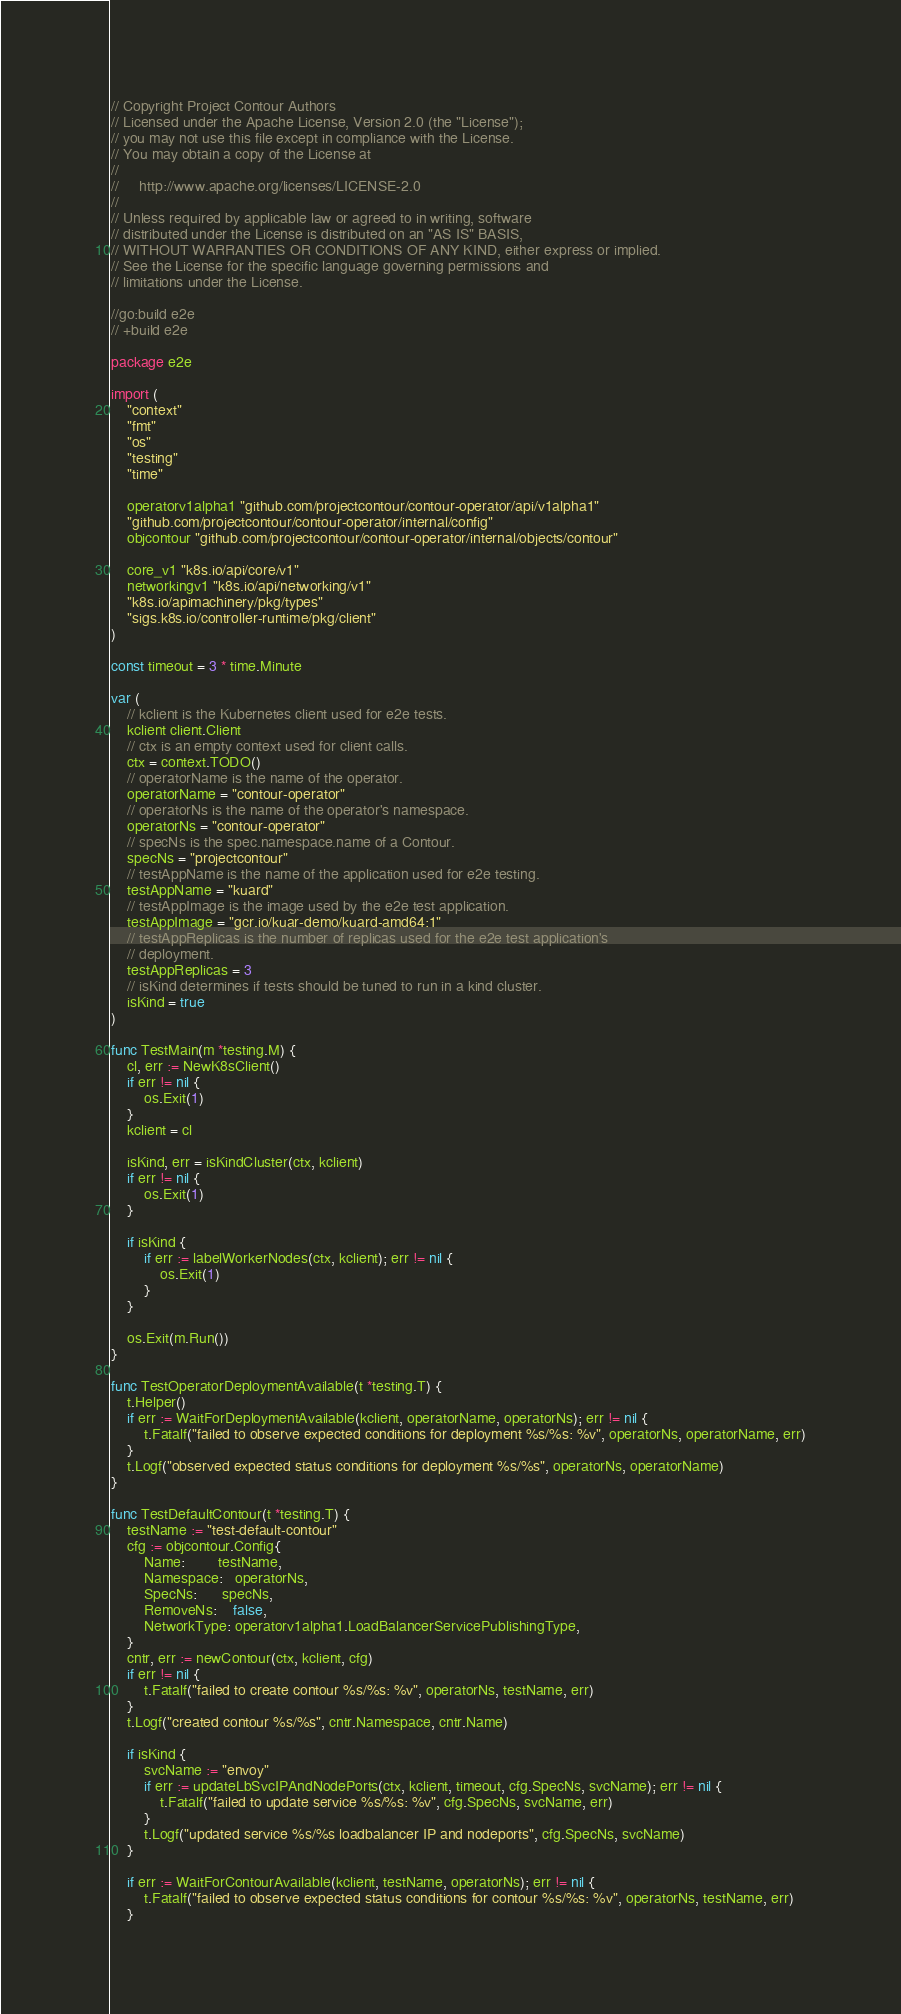<code> <loc_0><loc_0><loc_500><loc_500><_Go_>// Copyright Project Contour Authors
// Licensed under the Apache License, Version 2.0 (the "License");
// you may not use this file except in compliance with the License.
// You may obtain a copy of the License at
//
//     http://www.apache.org/licenses/LICENSE-2.0
//
// Unless required by applicable law or agreed to in writing, software
// distributed under the License is distributed on an "AS IS" BASIS,
// WITHOUT WARRANTIES OR CONDITIONS OF ANY KIND, either express or implied.
// See the License for the specific language governing permissions and
// limitations under the License.

//go:build e2e
// +build e2e

package e2e

import (
	"context"
	"fmt"
	"os"
	"testing"
	"time"

	operatorv1alpha1 "github.com/projectcontour/contour-operator/api/v1alpha1"
	"github.com/projectcontour/contour-operator/internal/config"
	objcontour "github.com/projectcontour/contour-operator/internal/objects/contour"

	core_v1 "k8s.io/api/core/v1"
	networkingv1 "k8s.io/api/networking/v1"
	"k8s.io/apimachinery/pkg/types"
	"sigs.k8s.io/controller-runtime/pkg/client"
)

const timeout = 3 * time.Minute

var (
	// kclient is the Kubernetes client used for e2e tests.
	kclient client.Client
	// ctx is an empty context used for client calls.
	ctx = context.TODO()
	// operatorName is the name of the operator.
	operatorName = "contour-operator"
	// operatorNs is the name of the operator's namespace.
	operatorNs = "contour-operator"
	// specNs is the spec.namespace.name of a Contour.
	specNs = "projectcontour"
	// testAppName is the name of the application used for e2e testing.
	testAppName = "kuard"
	// testAppImage is the image used by the e2e test application.
	testAppImage = "gcr.io/kuar-demo/kuard-amd64:1"
	// testAppReplicas is the number of replicas used for the e2e test application's
	// deployment.
	testAppReplicas = 3
	// isKind determines if tests should be tuned to run in a kind cluster.
	isKind = true
)

func TestMain(m *testing.M) {
	cl, err := NewK8sClient()
	if err != nil {
		os.Exit(1)
	}
	kclient = cl

	isKind, err = isKindCluster(ctx, kclient)
	if err != nil {
		os.Exit(1)
	}

	if isKind {
		if err := labelWorkerNodes(ctx, kclient); err != nil {
			os.Exit(1)
		}
	}

	os.Exit(m.Run())
}

func TestOperatorDeploymentAvailable(t *testing.T) {
	t.Helper()
	if err := WaitForDeploymentAvailable(kclient, operatorName, operatorNs); err != nil {
		t.Fatalf("failed to observe expected conditions for deployment %s/%s: %v", operatorNs, operatorName, err)
	}
	t.Logf("observed expected status conditions for deployment %s/%s", operatorNs, operatorName)
}

func TestDefaultContour(t *testing.T) {
	testName := "test-default-contour"
	cfg := objcontour.Config{
		Name:        testName,
		Namespace:   operatorNs,
		SpecNs:      specNs,
		RemoveNs:    false,
		NetworkType: operatorv1alpha1.LoadBalancerServicePublishingType,
	}
	cntr, err := newContour(ctx, kclient, cfg)
	if err != nil {
		t.Fatalf("failed to create contour %s/%s: %v", operatorNs, testName, err)
	}
	t.Logf("created contour %s/%s", cntr.Namespace, cntr.Name)

	if isKind {
		svcName := "envoy"
		if err := updateLbSvcIPAndNodePorts(ctx, kclient, timeout, cfg.SpecNs, svcName); err != nil {
			t.Fatalf("failed to update service %s/%s: %v", cfg.SpecNs, svcName, err)
		}
		t.Logf("updated service %s/%s loadbalancer IP and nodeports", cfg.SpecNs, svcName)
	}

	if err := WaitForContourAvailable(kclient, testName, operatorNs); err != nil {
		t.Fatalf("failed to observe expected status conditions for contour %s/%s: %v", operatorNs, testName, err)
	}</code> 